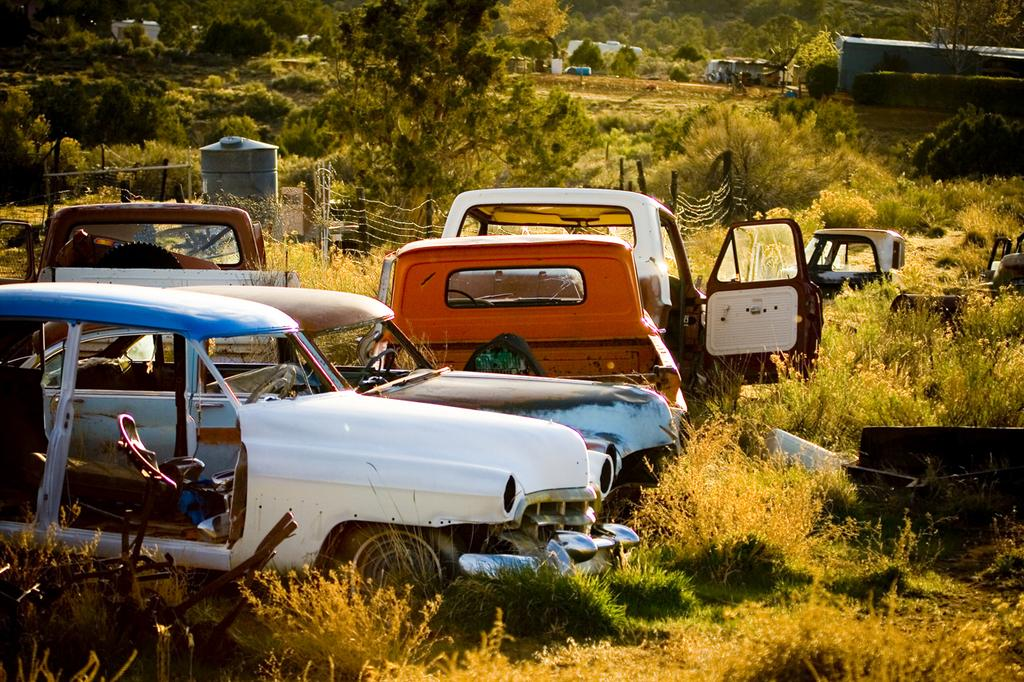What types of vehicles can be seen in the image? There are vehicles in the image, but the specific types are not mentioned. What type of natural environment is visible in the image? There is grass, plants, trees, and shelters visible in the image. What is the background of the image composed of? In the background, there is a fence, shelters, plants, and trees. Where is the hydrant located in the image? There is no hydrant present in the image. What type of furniture can be seen in the image? There is no furniture, such as a sofa, present in the image. 